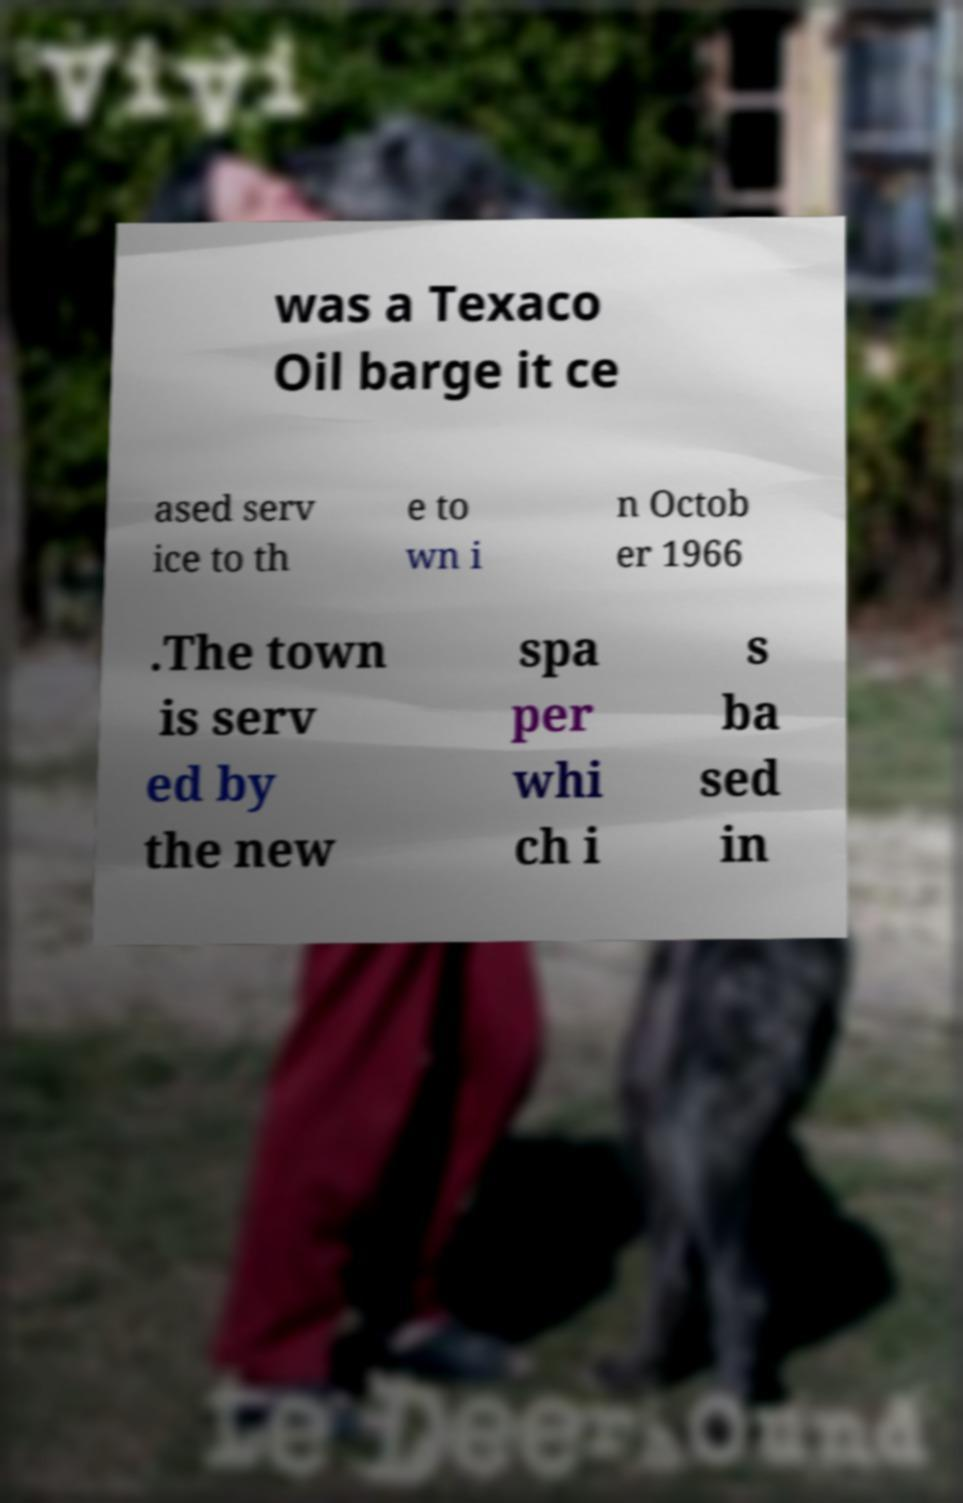There's text embedded in this image that I need extracted. Can you transcribe it verbatim? was a Texaco Oil barge it ce ased serv ice to th e to wn i n Octob er 1966 .The town is serv ed by the new spa per whi ch i s ba sed in 